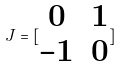<formula> <loc_0><loc_0><loc_500><loc_500>J = [ \begin{matrix} 0 & 1 \\ - 1 & 0 \end{matrix} ]</formula> 